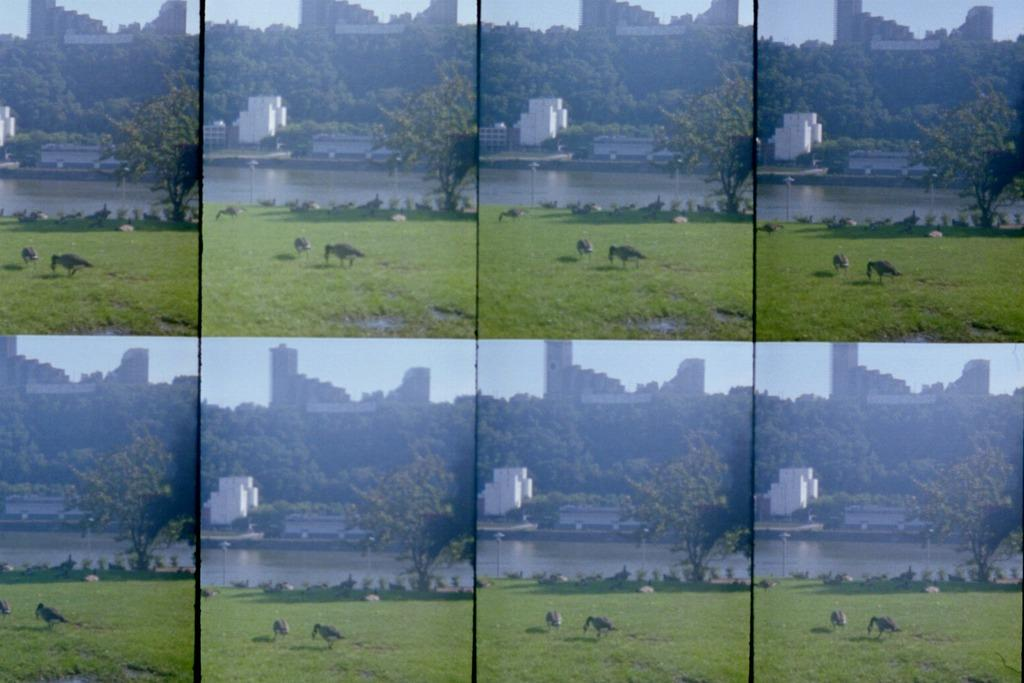What type of artwork is the image? The image is a collage. What animals can be seen in the image? There are birds standing on the grass in the image. What type of vegetation is visible in the background? There are trees in the background of the image. What type of structures are visible in the background? There are buildings in the background of the image. What natural element is visible in the background? Water is visible in the background of the image. What part of the sky is visible in the image? The sky is visible in the background of the image. What type of advice is the minister giving to the grandfather's foot in the image? There is no minister, grandfather, or foot present in the image. 